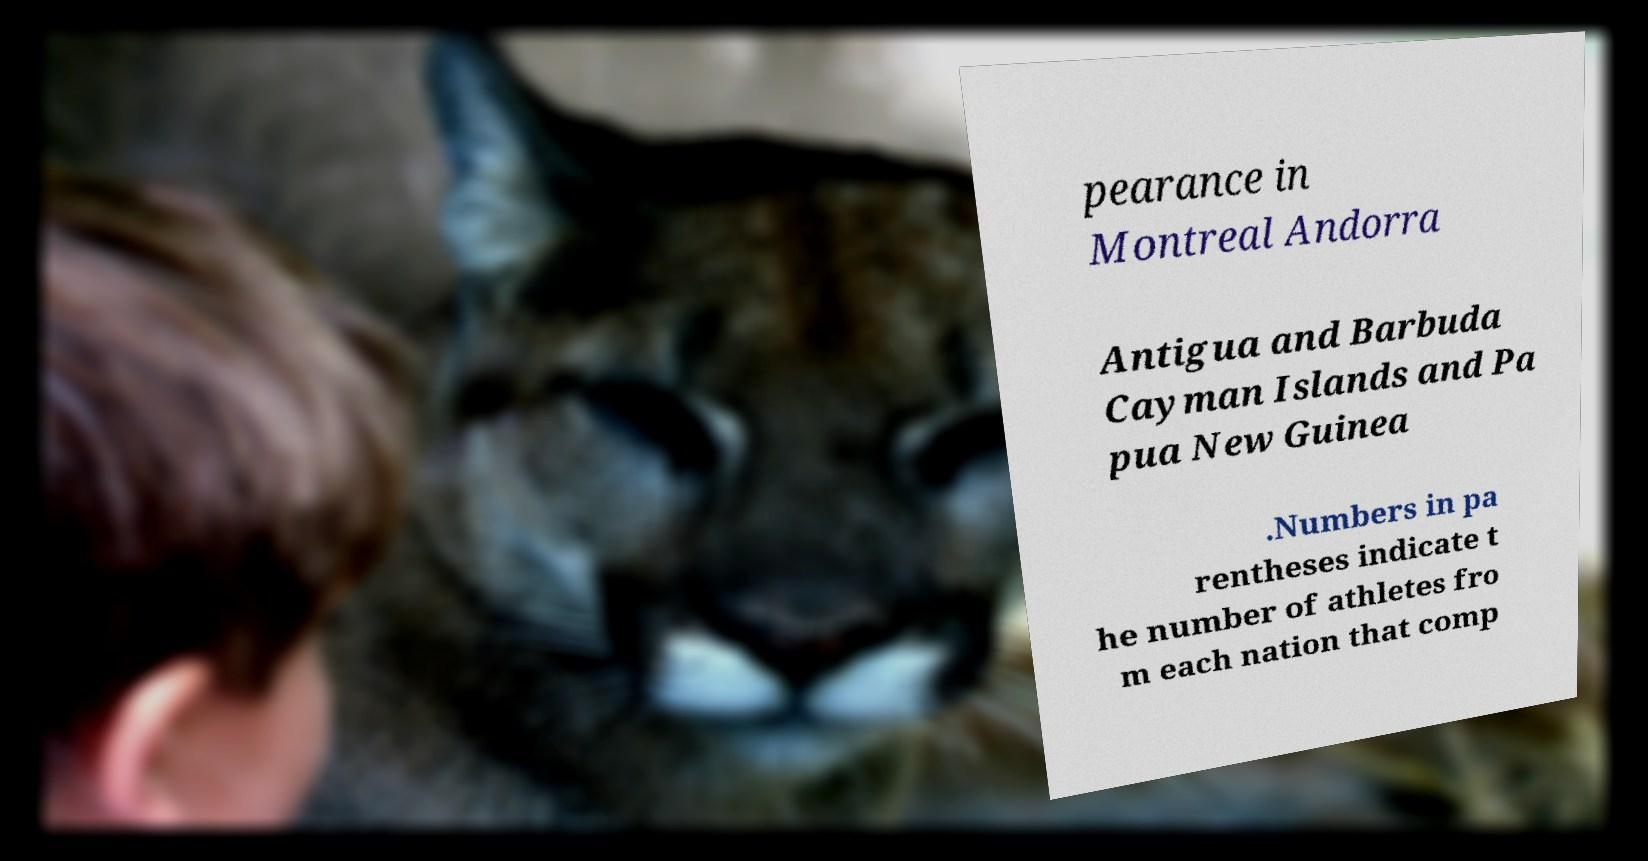Can you accurately transcribe the text from the provided image for me? pearance in Montreal Andorra Antigua and Barbuda Cayman Islands and Pa pua New Guinea .Numbers in pa rentheses indicate t he number of athletes fro m each nation that comp 